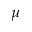Convert formula to latex. <formula><loc_0><loc_0><loc_500><loc_500>\mu</formula> 